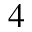Convert formula to latex. <formula><loc_0><loc_0><loc_500><loc_500>_ { 4 }</formula> 